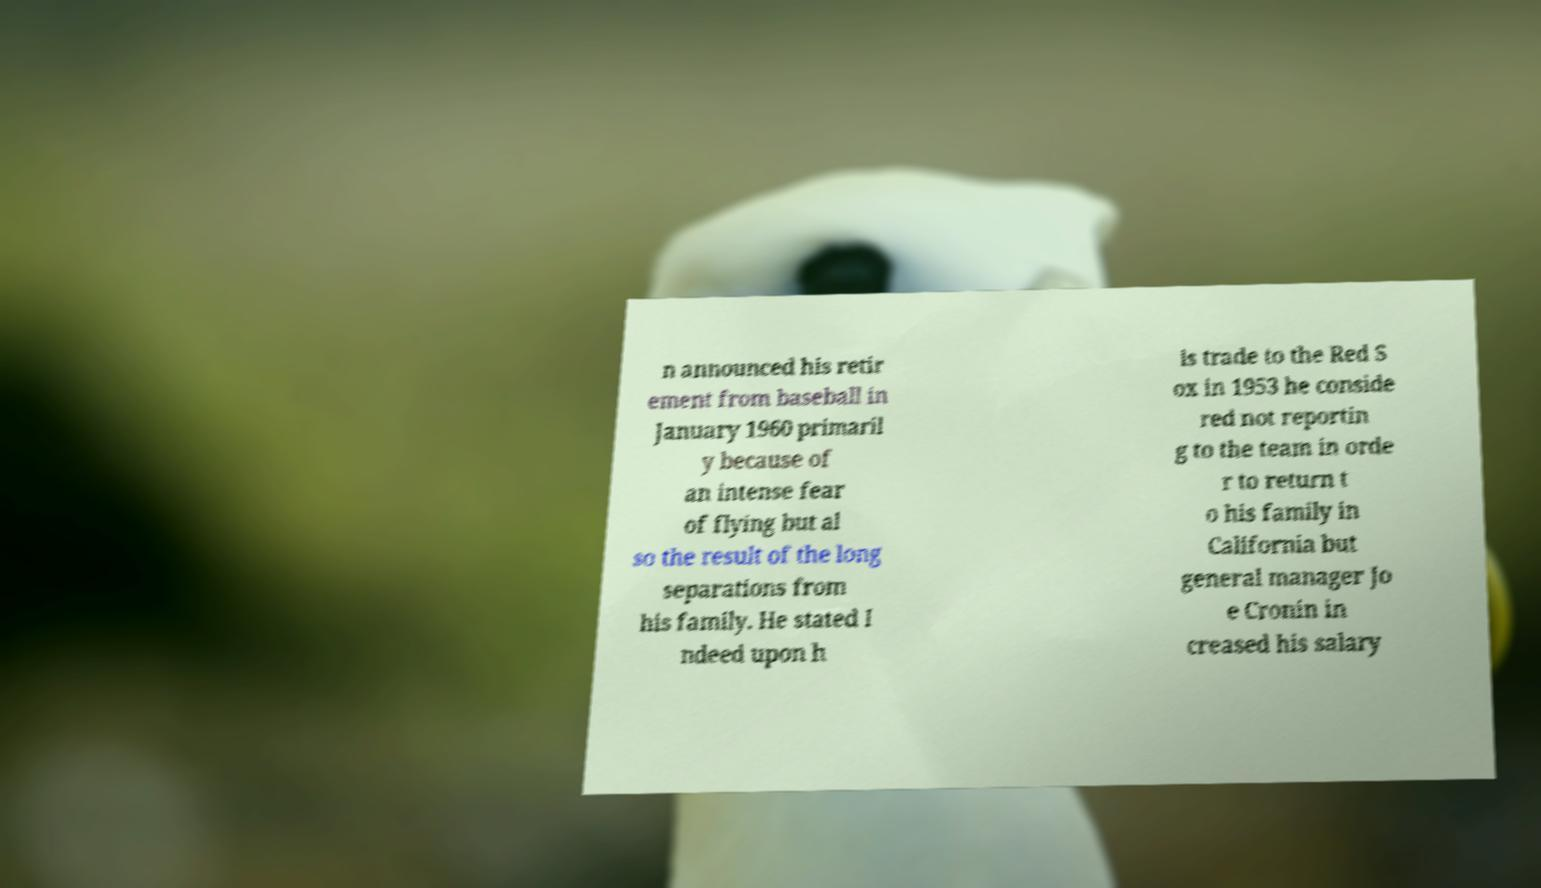For documentation purposes, I need the text within this image transcribed. Could you provide that? n announced his retir ement from baseball in January 1960 primaril y because of an intense fear of flying but al so the result of the long separations from his family. He stated I ndeed upon h is trade to the Red S ox in 1953 he conside red not reportin g to the team in orde r to return t o his family in California but general manager Jo e Cronin in creased his salary 